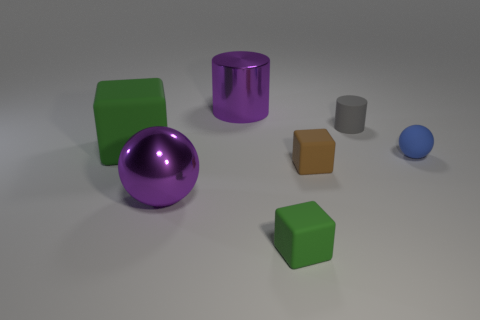Add 2 big purple cylinders. How many objects exist? 9 Subtract all cylinders. How many objects are left? 5 Subtract 1 brown blocks. How many objects are left? 6 Subtract all large objects. Subtract all small green matte cubes. How many objects are left? 3 Add 3 small blue matte spheres. How many small blue matte spheres are left? 4 Add 7 large green matte objects. How many large green matte objects exist? 8 